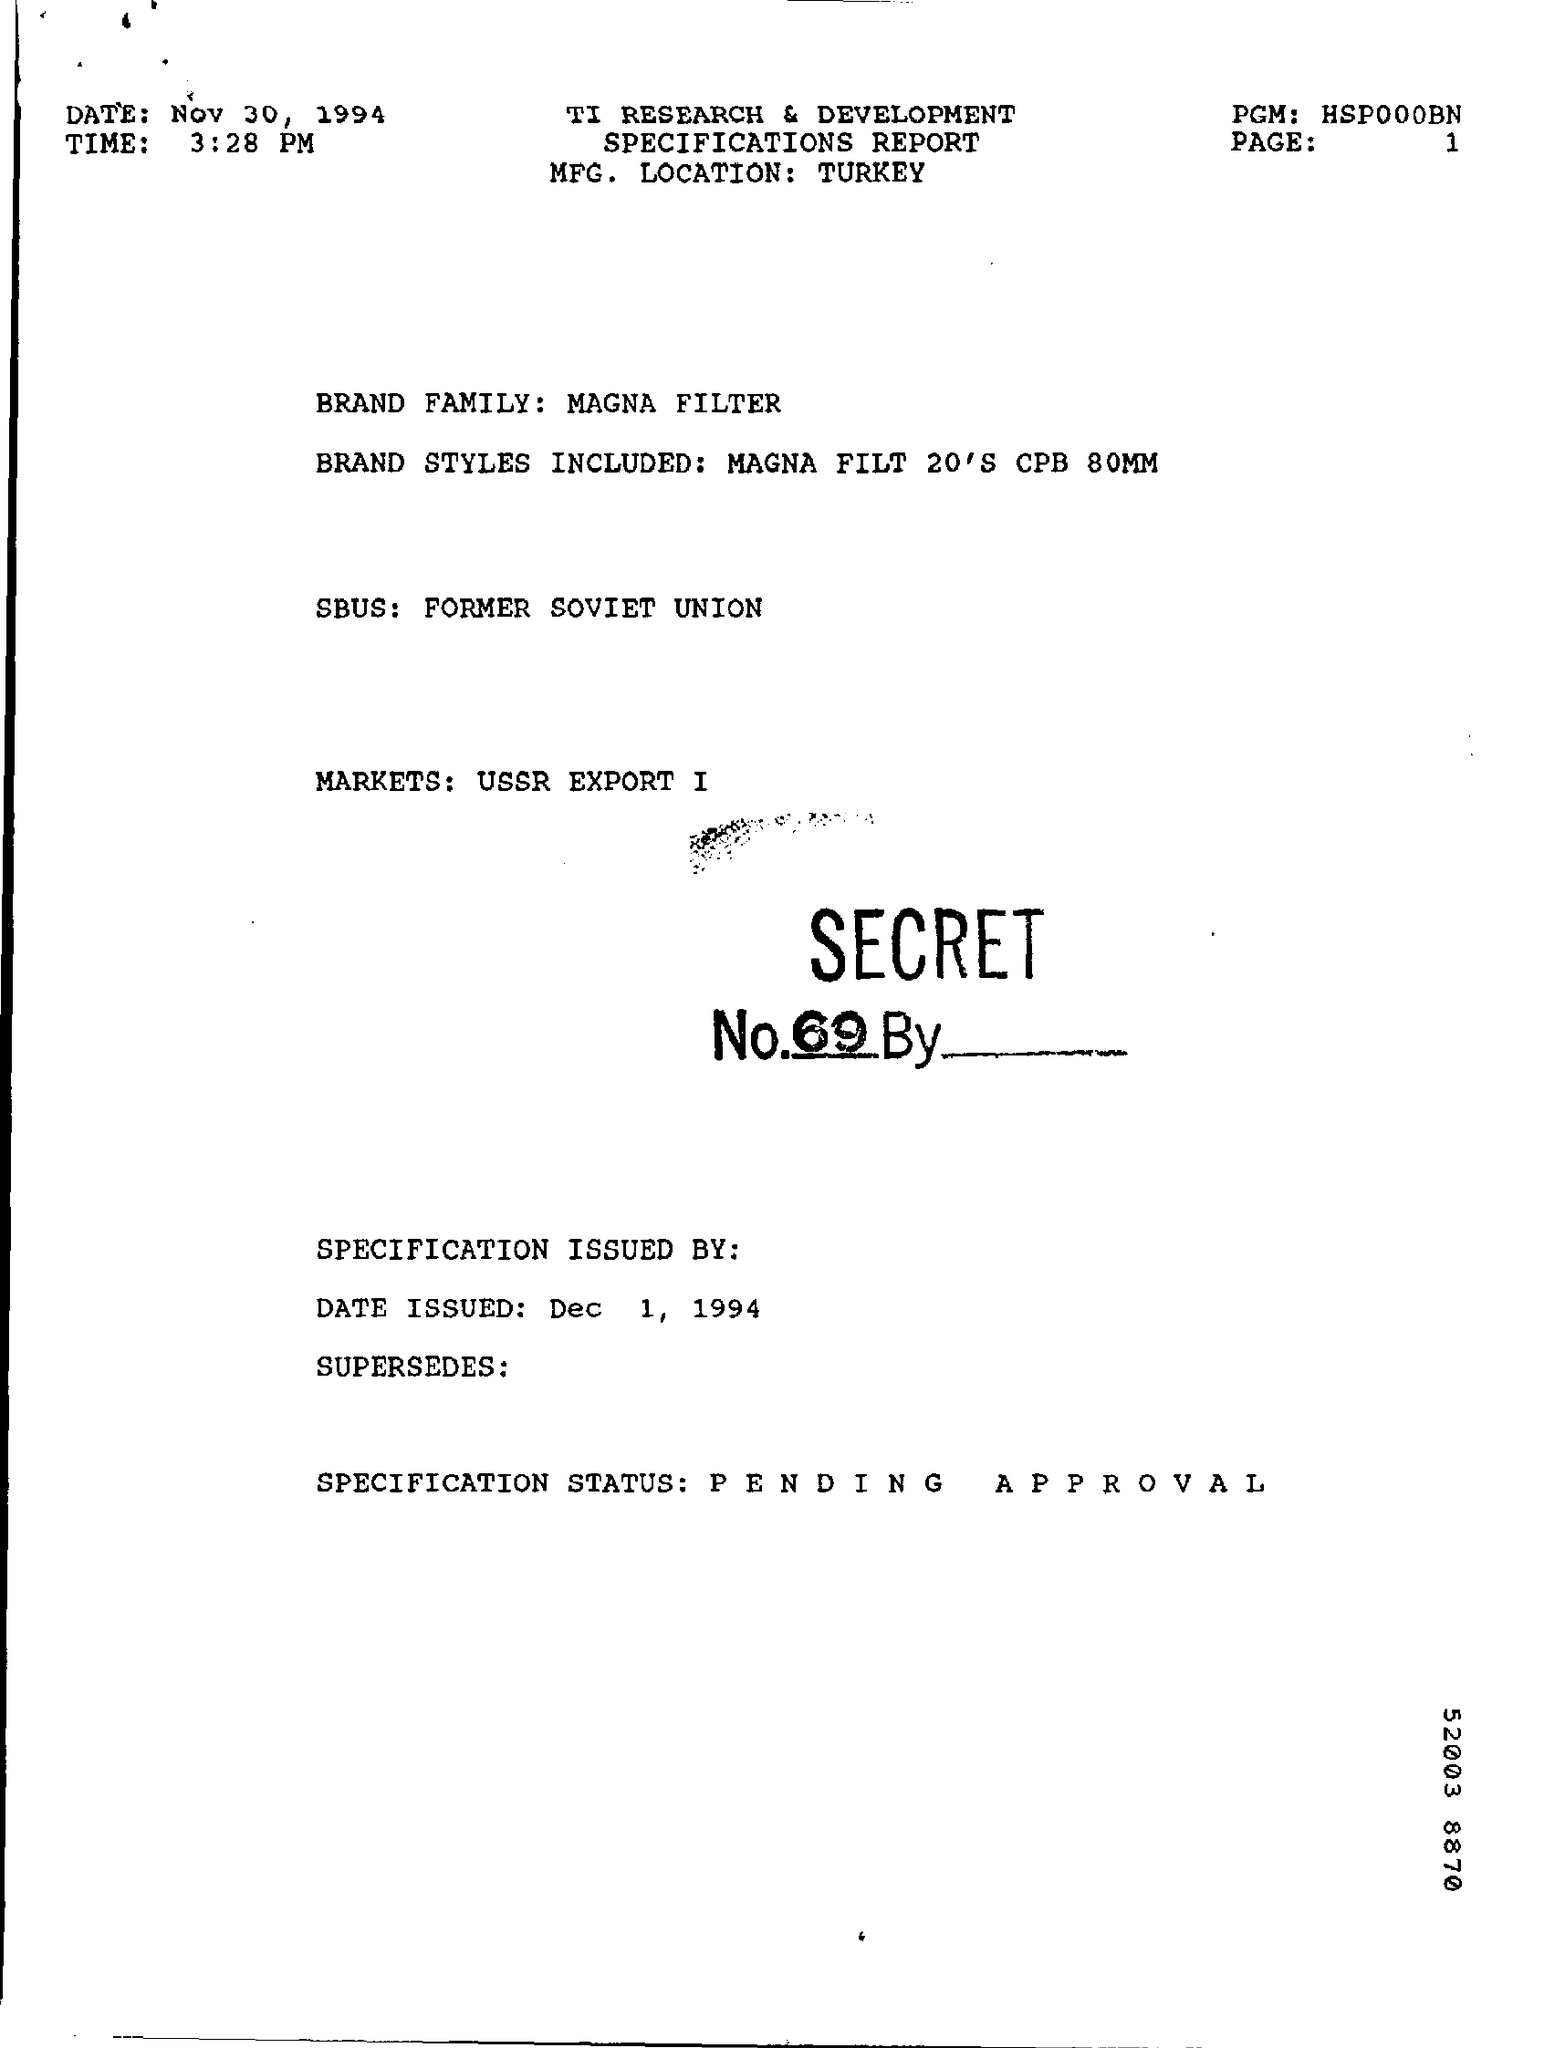On which date this report is prepared ?
Make the answer very short. Nov 30, 1994. What is the time mentioned in the given report ?
Give a very brief answer. 3:28 pm. What is the name of the brand family as per the report ?
Offer a very short reply. Magna filter. What are the brand styles included in the given report ?
Your answer should be very brief. MAGNA FILT 20'S CPB 80MM. What is the specification status shown as per the report ?
Your answer should be compact. PENDING APPROVAL. 